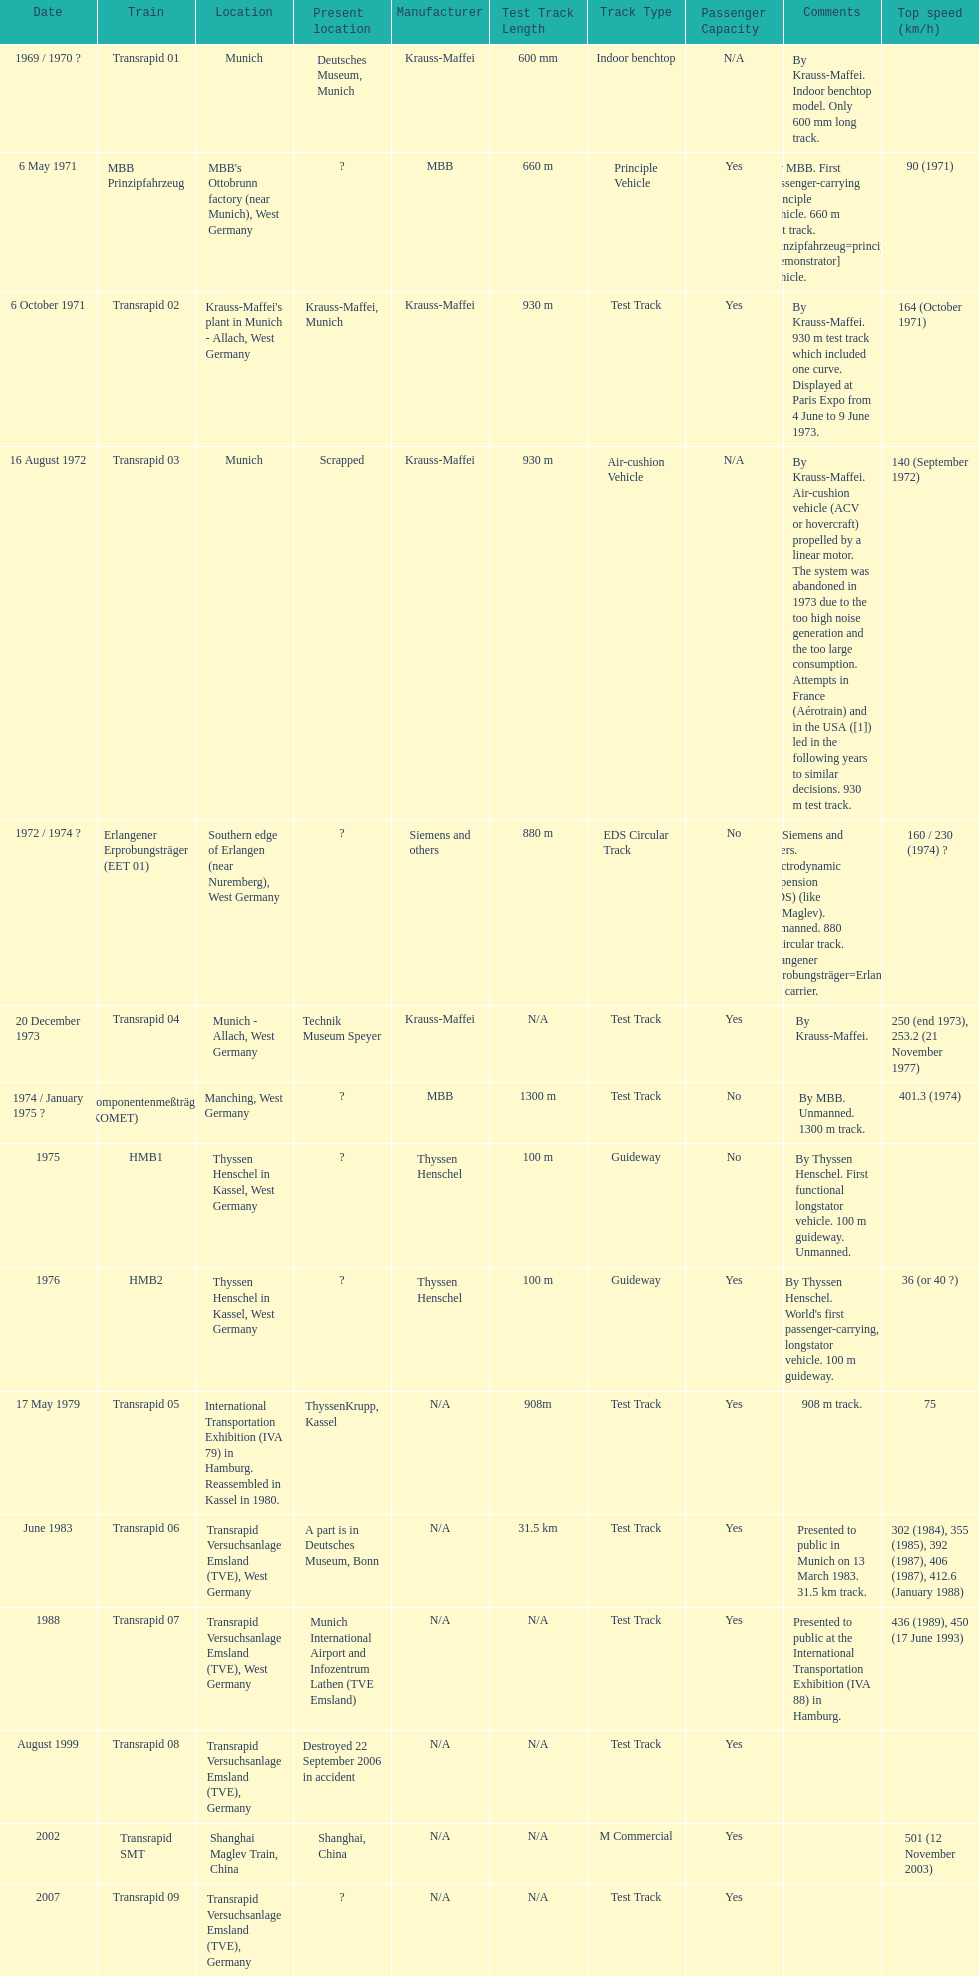What is the total of trains that were either disassembled or destroyed? 2. 